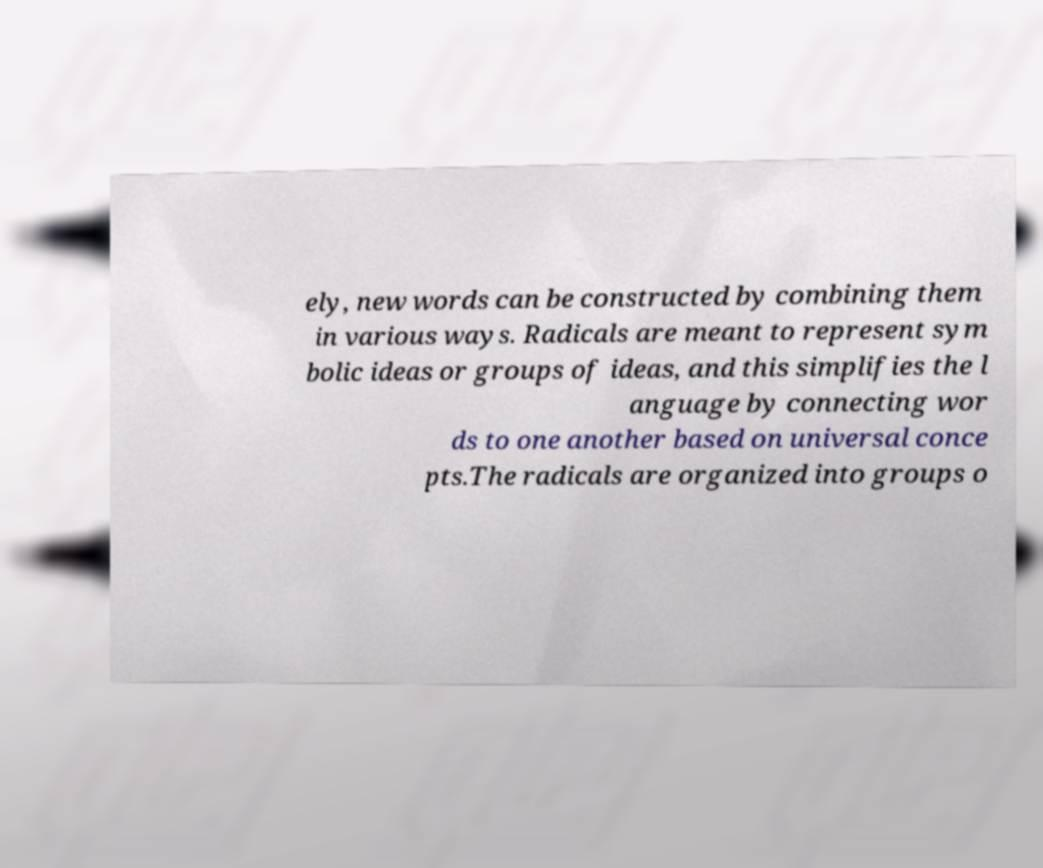Please read and relay the text visible in this image. What does it say? ely, new words can be constructed by combining them in various ways. Radicals are meant to represent sym bolic ideas or groups of ideas, and this simplifies the l anguage by connecting wor ds to one another based on universal conce pts.The radicals are organized into groups o 